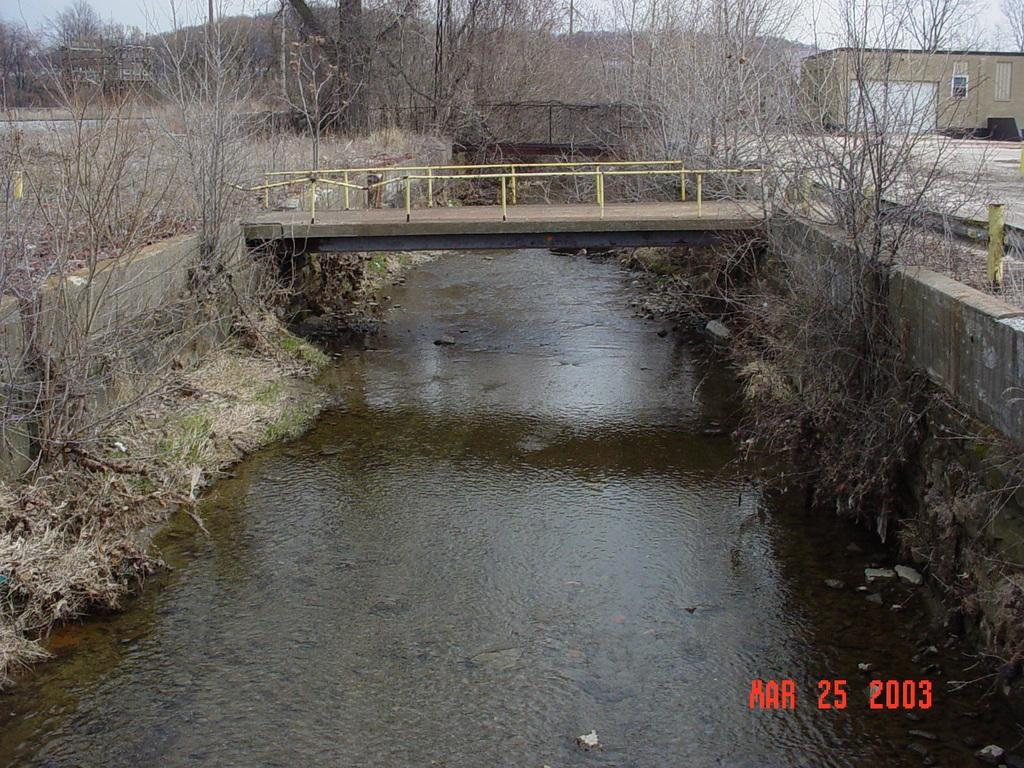What type of structure can be seen in the image? There is a bridge in the image. What natural element is visible in the image? There is water visible in the image. What type of vegetation is present in the image? There are trees in the image. Where is the house located in the image? The house is on the right side of the image. What color is the silk in the image? There is no silk present in the image. How many birds can be seen flying over the bridge in the image? There are no birds visible in the image. 